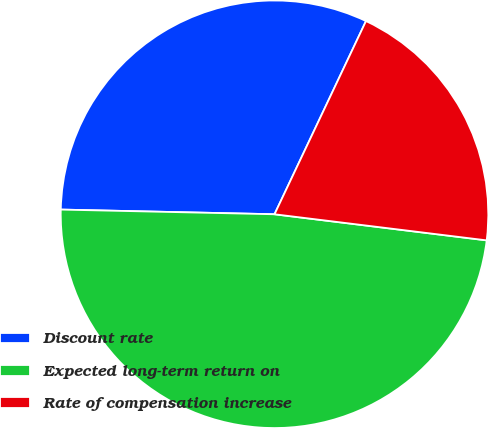Convert chart to OTSL. <chart><loc_0><loc_0><loc_500><loc_500><pie_chart><fcel>Discount rate<fcel>Expected long-term return on<fcel>Rate of compensation increase<nl><fcel>31.69%<fcel>48.4%<fcel>19.91%<nl></chart> 